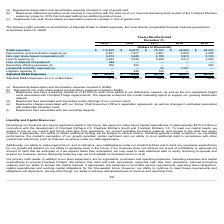According to Freshpet's financial document, What does launch expense represent? new store marketing allowance of $1,000 for each store added to our distribution network, as well as the non-capitalized freight costs associated with Freshpet Fridge replacements. The document states: "ensation expense included in SG&A. (c) Represents new store marketing allowance of $1,000 for each store added to our distribution network, as well as..." Also, What does secondary offering expenses represent? fees associated with secondary public offerings of our common stock. The document states: "(d) Represents fees associated with secondary public offerings of our common stock...." Also, What does Leadership transition expenses represent? charges associated with our former Chief Executive Officer’s separation agreement, as well as changes in estimates associated with leadership transition costs. The document states: "(e) Represents charges associated with our former Chief Executive Officer’s separation agreement, as well as changes in estimates associated with lead..." Additionally, Which year had the greatest SG&A expenses? According to the financial document, 2019. The relevant text states: "2019 2018 2017 2016 2015..." Additionally, Which year had the greatest adjusted SG&A expenses? According to the financial document, 2019. The relevant text states: "2019 2018 2017 2016 2015..." Also, How many types of expenses are listed in the table? Counting the relevant items in the document: SG&A expenses,  Depreciation and amortization expense,  Non-cash share-based compensation,  Launch expense,  Loss on disposal of equipment ,  Secondary offering expenses,  Leadership transition expenses ,  Litigation expense, I find 8 instances. The key data points involved are: Depreciation and amortization expense, Launch expense, Leadership transition expenses. 